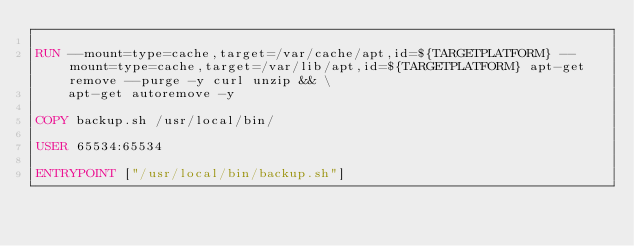Convert code to text. <code><loc_0><loc_0><loc_500><loc_500><_Dockerfile_>
RUN --mount=type=cache,target=/var/cache/apt,id=${TARGETPLATFORM} --mount=type=cache,target=/var/lib/apt,id=${TARGETPLATFORM} apt-get remove --purge -y curl unzip && \
    apt-get autoremove -y

COPY backup.sh /usr/local/bin/

USER 65534:65534

ENTRYPOINT ["/usr/local/bin/backup.sh"]
</code> 